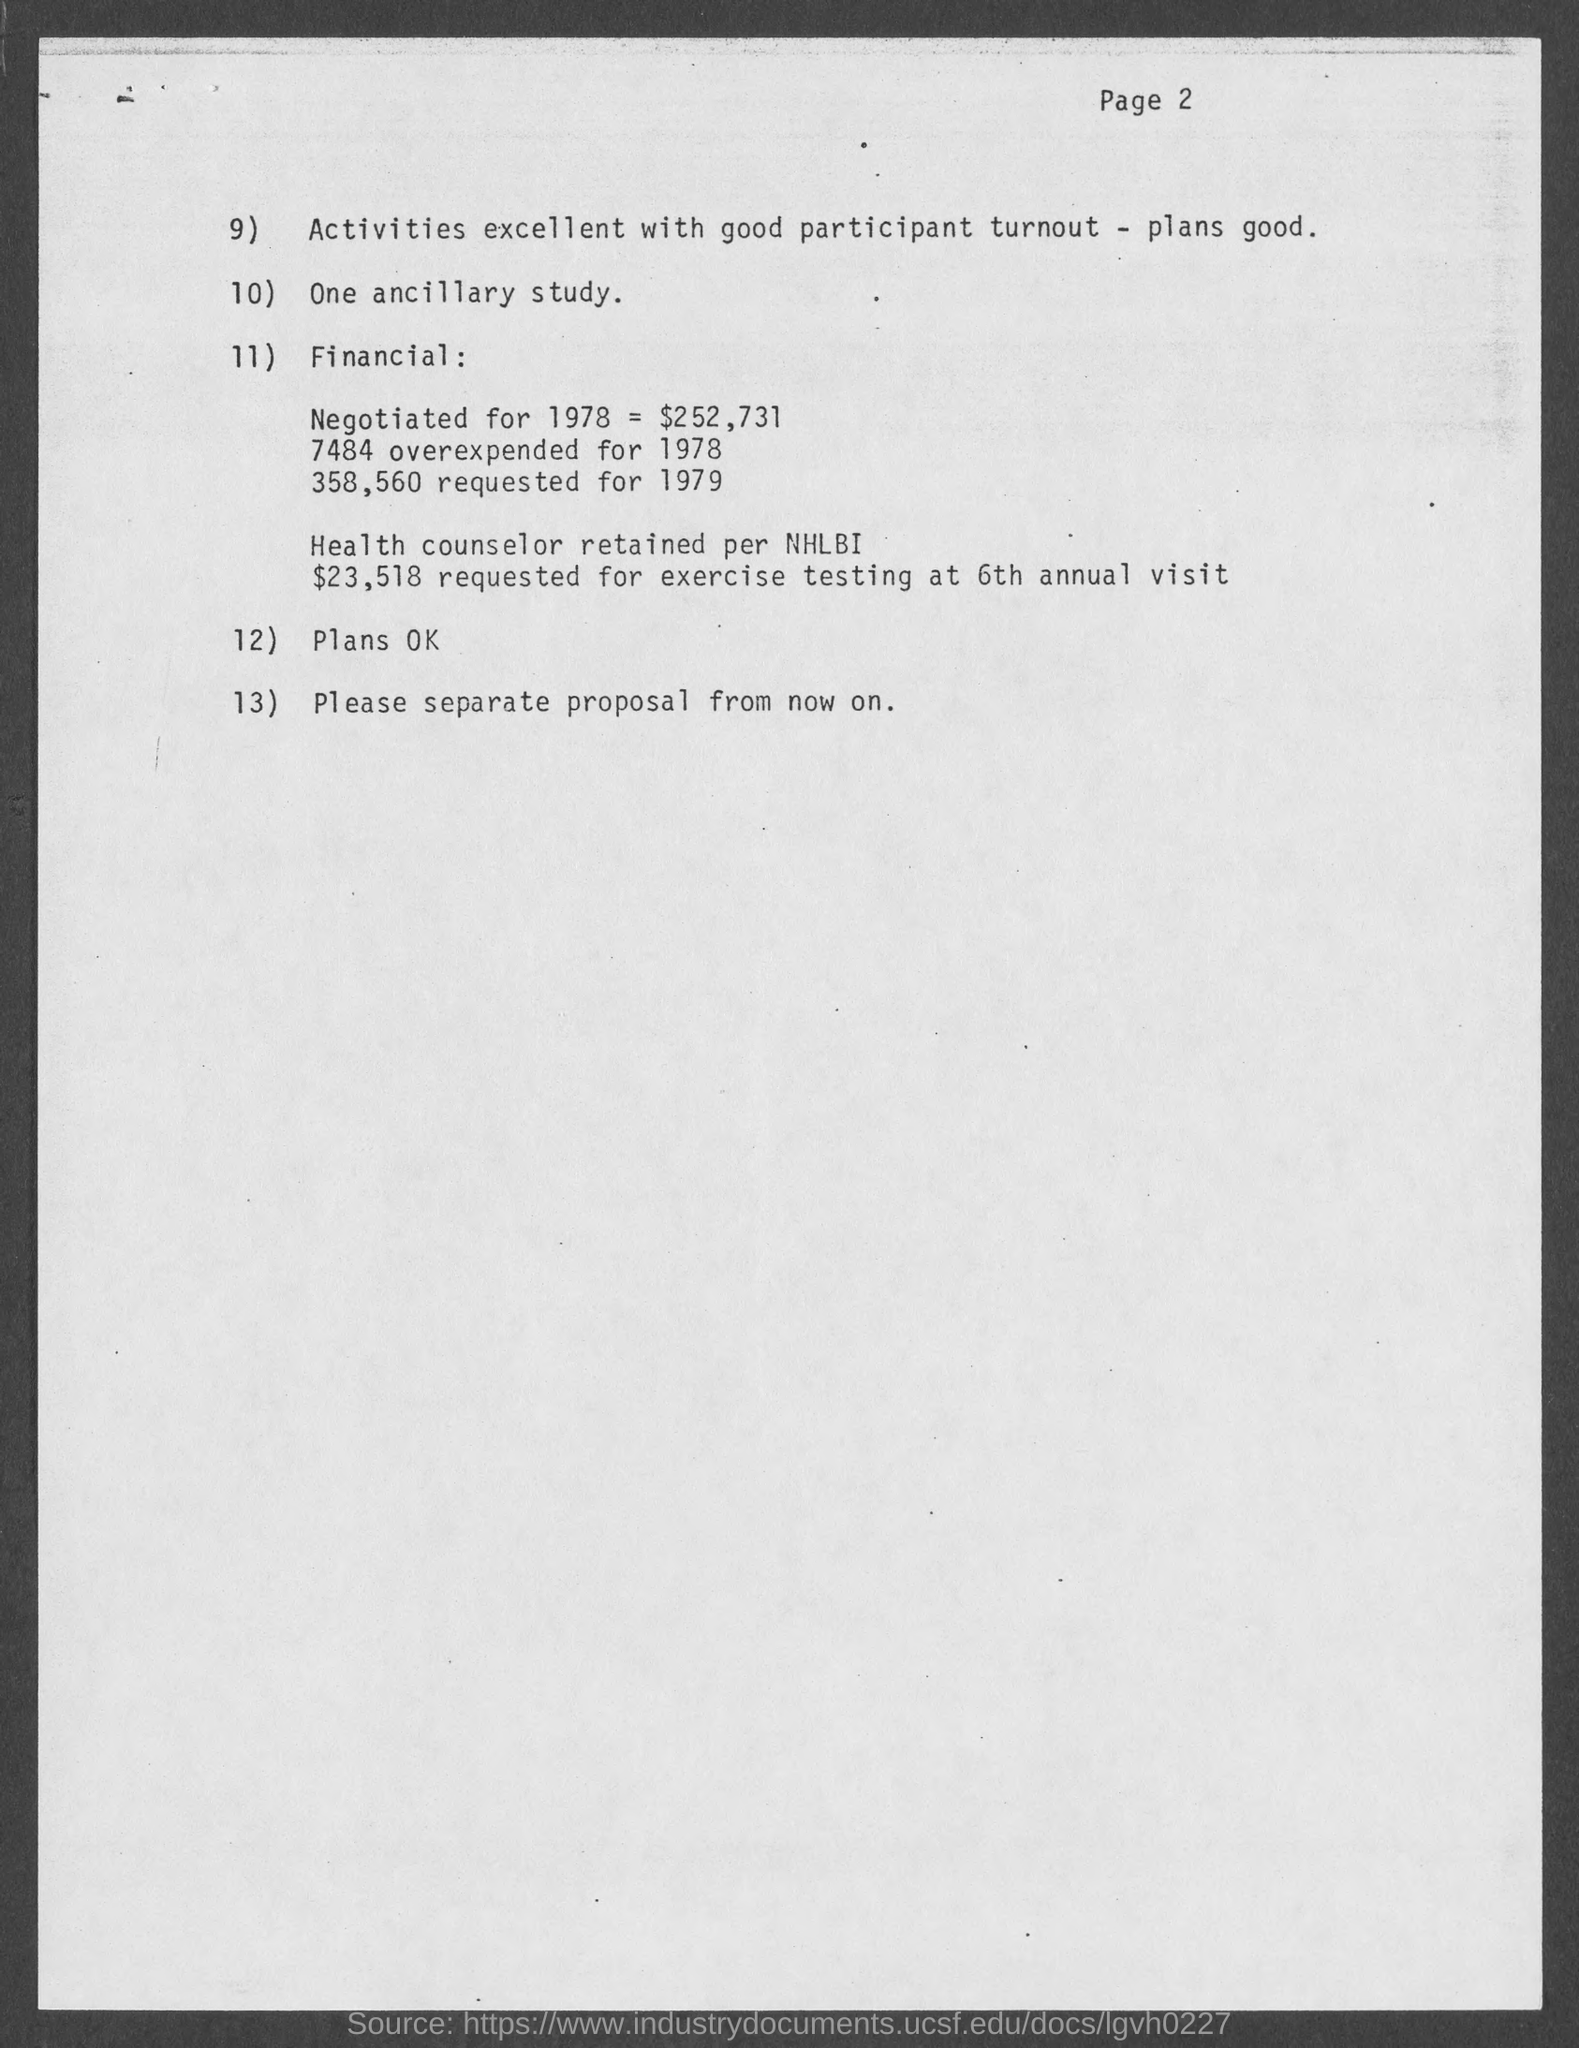What is the page number at the top of the page? The page number located at the top right corner of the document is 2, indicating that this is the second page of a multi-page report or memo. 